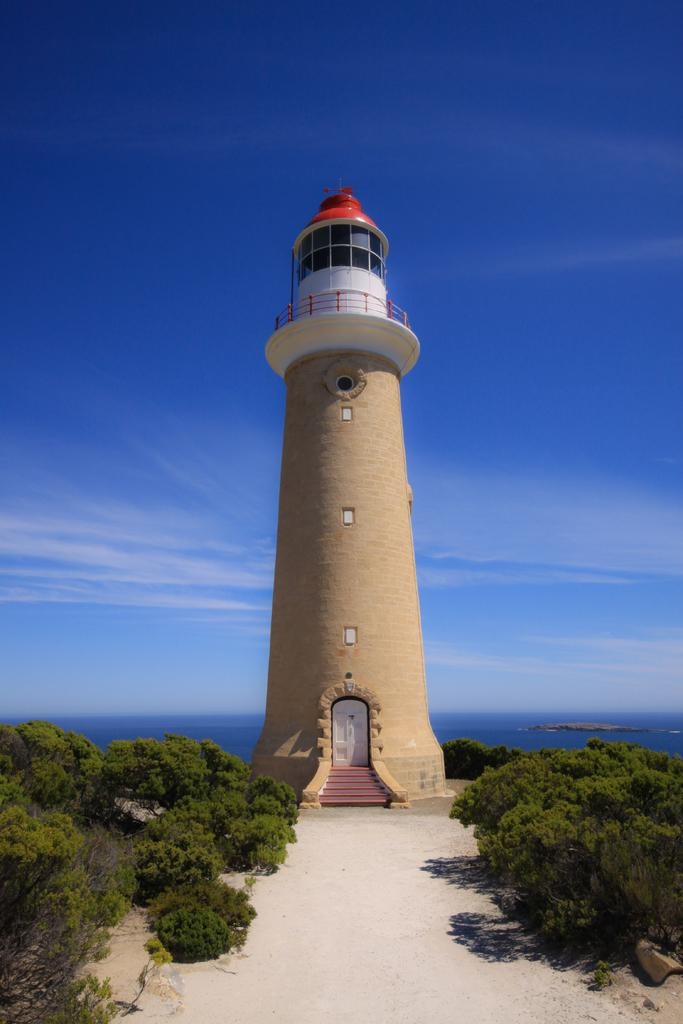What type of natural elements can be seen in the image? There are trees and water visible in the image. What man-made structure is present in the image? There is a lighthouse in the image. What type of geographical feature is visible in the image? There is a mountain in the image. What part of the natural environment is visible in the image? The sky is visible in the image. Based on the presence of the sky and the absence of artificial lighting, when do you think the image was taken? The image was likely taken during the day. What type of operation is being performed on the heart in the image? There is no heart or operation present in the image; it features trees, a lighthouse, water, a mountain, and the sky. How many times does the lift go up and down in the image? There is no lift present in the image; it features trees, a lighthouse, water, a mountain, and the sky. 